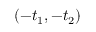<formula> <loc_0><loc_0><loc_500><loc_500>\left ( - t _ { 1 } , - t _ { 2 } \right )</formula> 